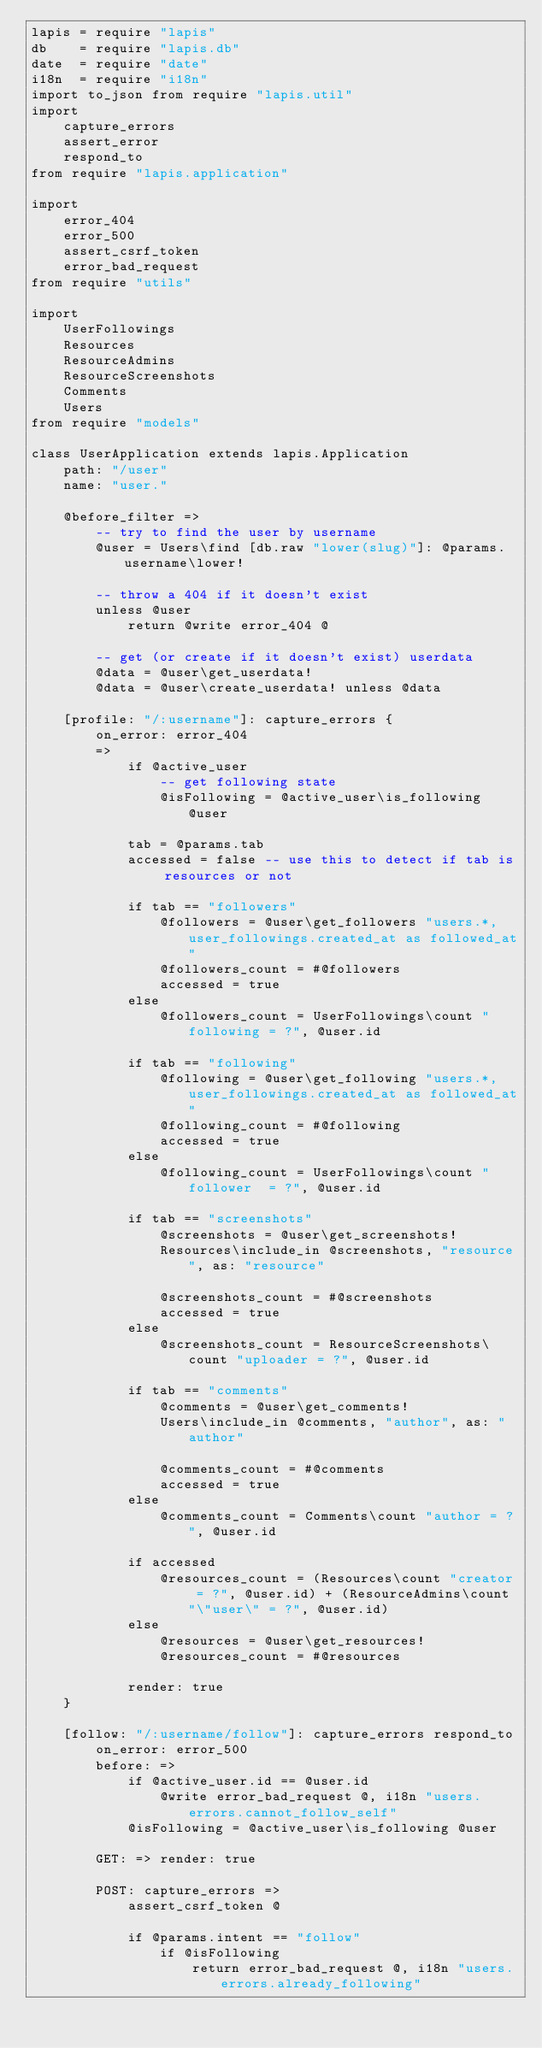Convert code to text. <code><loc_0><loc_0><loc_500><loc_500><_MoonScript_>lapis = require "lapis"
db    = require "lapis.db"
date  = require "date"
i18n  = require "i18n"
import to_json from require "lapis.util"
import
	capture_errors
	assert_error
	respond_to
from require "lapis.application"

import
	error_404
	error_500
	assert_csrf_token
	error_bad_request
from require "utils"

import
	UserFollowings
	Resources
	ResourceAdmins
	ResourceScreenshots
	Comments
	Users
from require "models"

class UserApplication extends lapis.Application
	path: "/user"
	name: "user."

	@before_filter =>
		-- try to find the user by username
		@user = Users\find [db.raw "lower(slug)"]: @params.username\lower!

		-- throw a 404 if it doesn't exist
		unless @user
			return @write error_404 @

		-- get (or create if it doesn't exist) userdata 
		@data = @user\get_userdata!
		@data = @user\create_userdata! unless @data

	[profile: "/:username"]: capture_errors {
		on_error: error_404
		=>
			if @active_user
				-- get following state
				@isFollowing = @active_user\is_following @user

			tab = @params.tab
			accessed = false -- use this to detect if tab is resources or not

			if tab == "followers"
				@followers = @user\get_followers "users.*, user_followings.created_at as followed_at"
				@followers_count = #@followers
				accessed = true
			else
				@followers_count = UserFollowings\count "following = ?", @user.id

			if tab == "following"
				@following = @user\get_following "users.*, user_followings.created_at as followed_at"
				@following_count = #@following
				accessed = true
			else
				@following_count = UserFollowings\count "follower  = ?", @user.id

			if tab == "screenshots"
				@screenshots = @user\get_screenshots!
				Resources\include_in @screenshots, "resource", as: "resource"

				@screenshots_count = #@screenshots
				accessed = true
			else
				@screenshots_count = ResourceScreenshots\count "uploader = ?", @user.id
			
			if tab == "comments"
				@comments = @user\get_comments!
				Users\include_in @comments, "author", as: "author"

				@comments_count = #@comments
				accessed = true
			else
				@comments_count = Comments\count "author = ?", @user.id

			if accessed
				@resources_count = (Resources\count "creator = ?", @user.id) + (ResourceAdmins\count "\"user\" = ?", @user.id)
			else
				@resources = @user\get_resources!
				@resources_count = #@resources

			render: true
	}

	[follow: "/:username/follow"]: capture_errors respond_to
		on_error: error_500
		before: =>
			if @active_user.id == @user.id
				@write error_bad_request @, i18n "users.errors.cannot_follow_self"
			@isFollowing = @active_user\is_following @user

		GET: =>	render: true

		POST: capture_errors =>
			assert_csrf_token @

			if @params.intent == "follow"
				if @isFollowing
					return error_bad_request @, i18n "users.errors.already_following"
</code> 